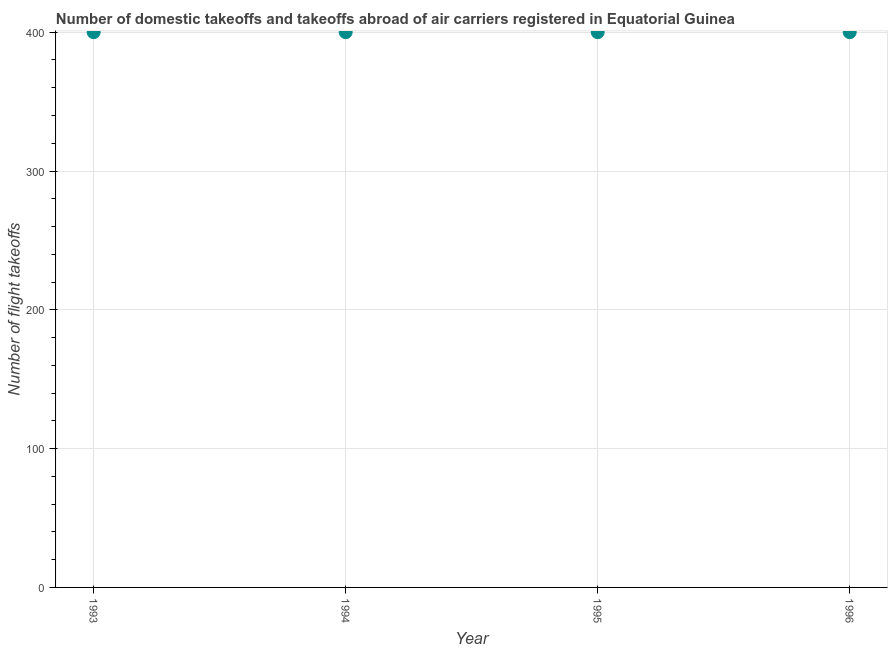Across all years, what is the maximum number of flight takeoffs?
Your response must be concise. 400. Across all years, what is the minimum number of flight takeoffs?
Provide a short and direct response. 400. In which year was the number of flight takeoffs maximum?
Your answer should be very brief. 1993. In which year was the number of flight takeoffs minimum?
Keep it short and to the point. 1993. What is the sum of the number of flight takeoffs?
Provide a succinct answer. 1600. What is the difference between the number of flight takeoffs in 1995 and 1996?
Keep it short and to the point. 0. In how many years, is the number of flight takeoffs greater than 160 ?
Make the answer very short. 4. Do a majority of the years between 1993 and 1994 (inclusive) have number of flight takeoffs greater than 260 ?
Ensure brevity in your answer.  Yes. What is the ratio of the number of flight takeoffs in 1994 to that in 1996?
Provide a succinct answer. 1. Is the difference between the number of flight takeoffs in 1993 and 1995 greater than the difference between any two years?
Give a very brief answer. Yes. What is the difference between the highest and the second highest number of flight takeoffs?
Offer a very short reply. 0. Is the sum of the number of flight takeoffs in 1993 and 1996 greater than the maximum number of flight takeoffs across all years?
Offer a very short reply. Yes. In how many years, is the number of flight takeoffs greater than the average number of flight takeoffs taken over all years?
Your answer should be very brief. 0. How many dotlines are there?
Keep it short and to the point. 1. How many years are there in the graph?
Provide a succinct answer. 4. What is the difference between two consecutive major ticks on the Y-axis?
Offer a terse response. 100. Are the values on the major ticks of Y-axis written in scientific E-notation?
Keep it short and to the point. No. Does the graph contain any zero values?
Provide a short and direct response. No. What is the title of the graph?
Give a very brief answer. Number of domestic takeoffs and takeoffs abroad of air carriers registered in Equatorial Guinea. What is the label or title of the X-axis?
Offer a very short reply. Year. What is the label or title of the Y-axis?
Offer a terse response. Number of flight takeoffs. What is the difference between the Number of flight takeoffs in 1993 and 1995?
Your answer should be compact. 0. What is the difference between the Number of flight takeoffs in 1993 and 1996?
Make the answer very short. 0. What is the difference between the Number of flight takeoffs in 1994 and 1995?
Offer a terse response. 0. What is the difference between the Number of flight takeoffs in 1994 and 1996?
Your answer should be very brief. 0. What is the difference between the Number of flight takeoffs in 1995 and 1996?
Provide a succinct answer. 0. What is the ratio of the Number of flight takeoffs in 1993 to that in 1994?
Give a very brief answer. 1. What is the ratio of the Number of flight takeoffs in 1993 to that in 1996?
Your answer should be compact. 1. What is the ratio of the Number of flight takeoffs in 1994 to that in 1995?
Make the answer very short. 1. What is the ratio of the Number of flight takeoffs in 1994 to that in 1996?
Your response must be concise. 1. What is the ratio of the Number of flight takeoffs in 1995 to that in 1996?
Ensure brevity in your answer.  1. 